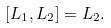<formula> <loc_0><loc_0><loc_500><loc_500>[ L _ { 1 } , L _ { 2 } ] = L _ { 2 } .</formula> 